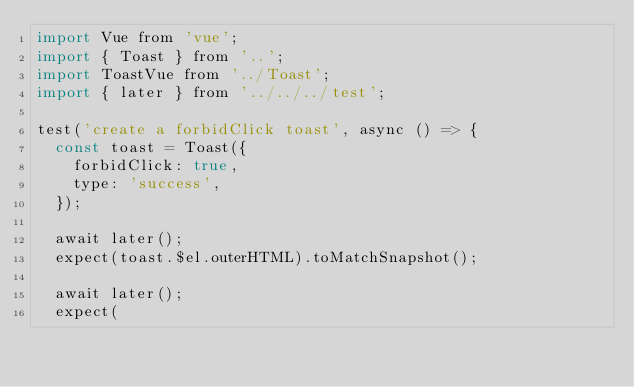<code> <loc_0><loc_0><loc_500><loc_500><_JavaScript_>import Vue from 'vue';
import { Toast } from '..';
import ToastVue from '../Toast';
import { later } from '../../../test';

test('create a forbidClick toast', async () => {
  const toast = Toast({
    forbidClick: true,
    type: 'success',
  });

  await later();
  expect(toast.$el.outerHTML).toMatchSnapshot();

  await later();
  expect(</code> 